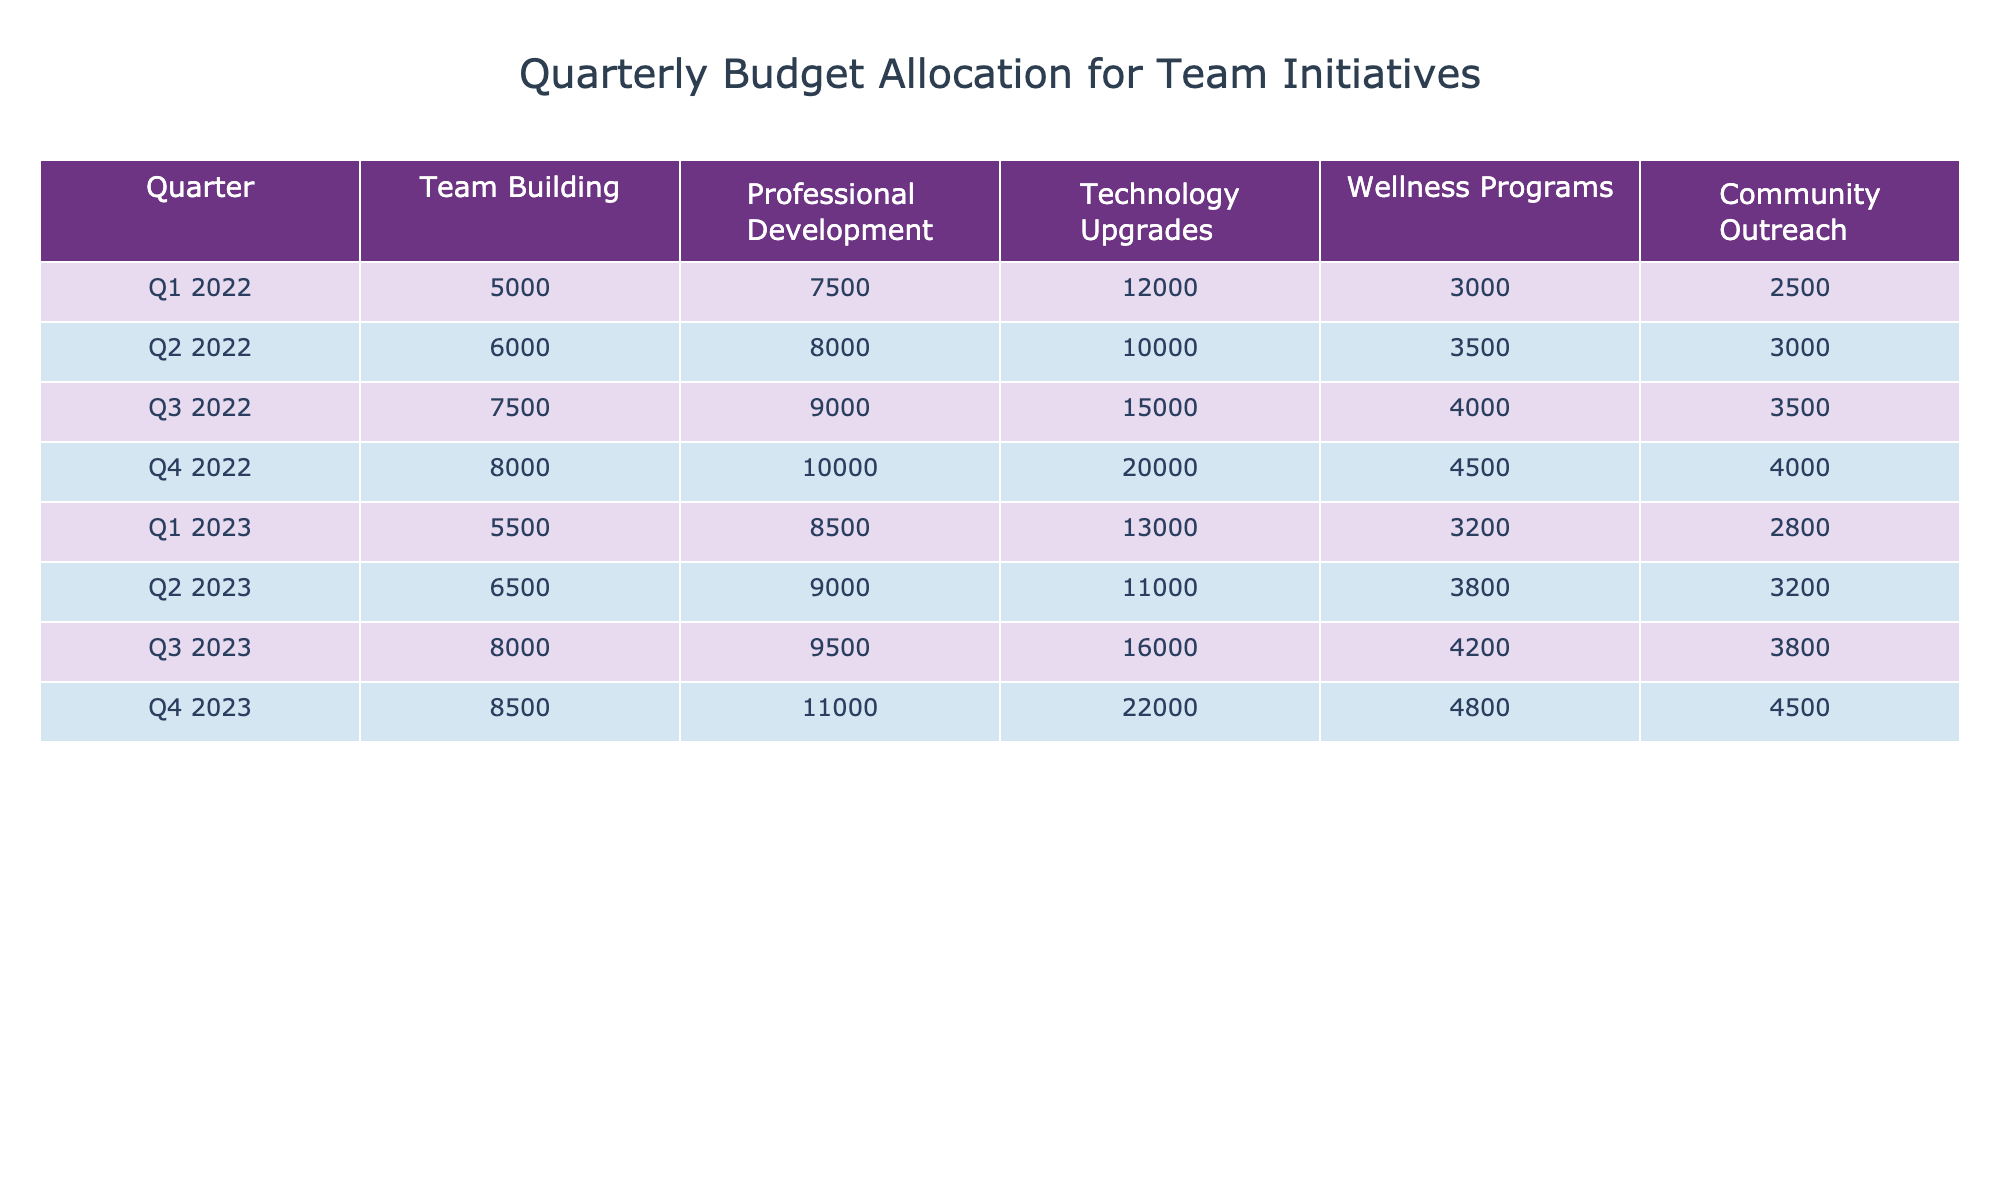What is the total budget for Technology Upgrades in Q2 2023? The value for Technology Upgrades in Q2 2023 is 11,000, which can be directly retrieved from the table.
Answer: 11,000 Which quarter had the highest allocation for Community Outreach? By comparing the values for Community Outreach across all quarters, Q4 2023 has the highest allocation of 4,500.
Answer: Q4 2023 What is the average budget allocated for Professional Development across all four quarters of 2022? The values for Professional Development in 2022 are 7,500, 8,000, 9,000, and 10,000. Adding these gives 34,500 and averaging over four quarters results in 34,500 / 4 = 8,625.
Answer: 8,625 Did the budget for Team Building increase from Q1 2022 to Q4 2022? The value for Team Building in Q1 2022 is 5,000 and in Q4 2022 is 8,000; thus, there was an increase.
Answer: Yes What is the difference in budget allocation for Wellness Programs between Q3 2022 and Q1 2023? The allocation for Wellness Programs in Q3 2022 is 4,000 and in Q1 2023 is 3,200. The difference is 4,000 - 3,200 = 800.
Answer: 800 What was the total budget allocated for all initiatives in Q3 2023? The values for Q3 2023 are 8,000 (Team Building) + 9,500 (Professional Development) + 16,000 (Technology Upgrades) + 4,200 (Wellness Programs) + 3,800 (Community Outreach), totaling 41,500.
Answer: 41,500 Has the budget for Technology Upgrades consistently increased every quarter from Q1 2022 to Q4 2023? Reviewing each quarter shows the values: 12,000, 10,000, 15,000, 20,000, 13,000, 11,000, 16,000, and 22,000, indicating a consistent increase from Q1 2022 to Q4 2023.
Answer: Yes What is the median budget allocation for Team Building across all quarters? The budgets for Team Building are 5,000, 6,000, 7,500, 8,000, 5,500, 6,500, 8,000, and 8,500. When sorted, they are 5,000, 5,500, 6,000, 6,500, 7,500, 8,000, 8,000, 8,500; the median (average of 6,500 and 7,500) is 7,000.
Answer: 7,000 Which initiative received the lowest budget allocation in Q1 2022? The values for Q1 2022 are 5,000, 7,500, 12,000, 3,000, and 2,500, where Community Outreach at 2,500 is the lowest.
Answer: Community Outreach What was the increase in budget for Professional Development from Q1 2022 to Q4 2023? The allocation for Professional Development in Q1 2022 was 7,500 and in Q4 2023 was 11,000; the increase is 11,000 - 7,500 = 3,500.
Answer: 3,500 